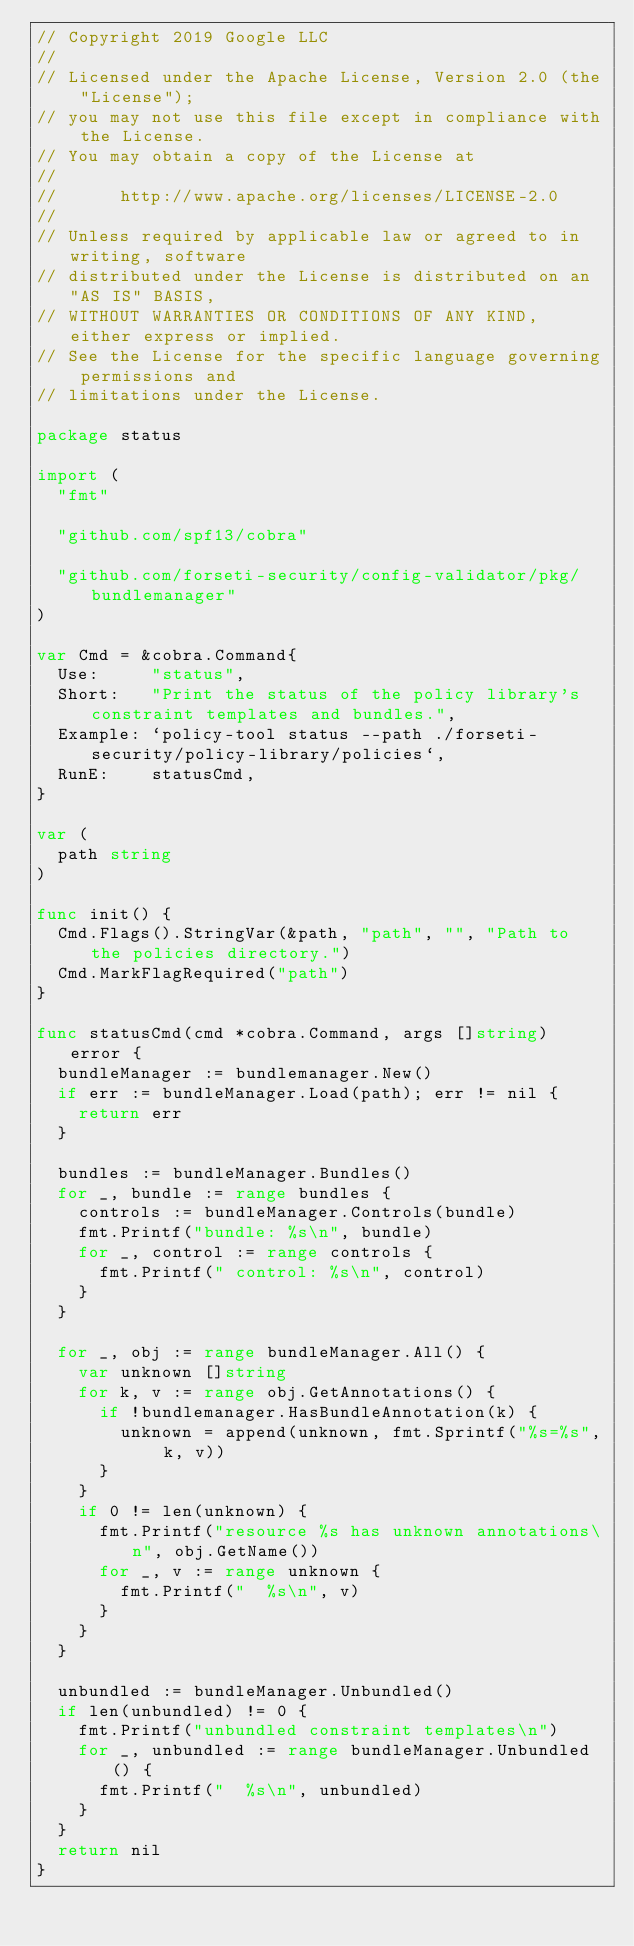Convert code to text. <code><loc_0><loc_0><loc_500><loc_500><_Go_>// Copyright 2019 Google LLC
//
// Licensed under the Apache License, Version 2.0 (the "License");
// you may not use this file except in compliance with the License.
// You may obtain a copy of the License at
//
//      http://www.apache.org/licenses/LICENSE-2.0
//
// Unless required by applicable law or agreed to in writing, software
// distributed under the License is distributed on an "AS IS" BASIS,
// WITHOUT WARRANTIES OR CONDITIONS OF ANY KIND, either express or implied.
// See the License for the specific language governing permissions and
// limitations under the License.

package status

import (
	"fmt"

	"github.com/spf13/cobra"

	"github.com/forseti-security/config-validator/pkg/bundlemanager"
)

var Cmd = &cobra.Command{
	Use:     "status",
	Short:   "Print the status of the policy library's constraint templates and bundles.",
	Example: `policy-tool status --path ./forseti-security/policy-library/policies`,
	RunE:    statusCmd,
}

var (
	path string
)

func init() {
	Cmd.Flags().StringVar(&path, "path", "", "Path to the policies directory.")
	Cmd.MarkFlagRequired("path")
}

func statusCmd(cmd *cobra.Command, args []string) error {
	bundleManager := bundlemanager.New()
	if err := bundleManager.Load(path); err != nil {
		return err
	}

	bundles := bundleManager.Bundles()
	for _, bundle := range bundles {
		controls := bundleManager.Controls(bundle)
		fmt.Printf("bundle: %s\n", bundle)
		for _, control := range controls {
			fmt.Printf(" control: %s\n", control)
		}
	}

	for _, obj := range bundleManager.All() {
		var unknown []string
		for k, v := range obj.GetAnnotations() {
			if !bundlemanager.HasBundleAnnotation(k) {
				unknown = append(unknown, fmt.Sprintf("%s=%s", k, v))
			}
		}
		if 0 != len(unknown) {
			fmt.Printf("resource %s has unknown annotations\n", obj.GetName())
			for _, v := range unknown {
				fmt.Printf("  %s\n", v)
			}
		}
	}

	unbundled := bundleManager.Unbundled()
	if len(unbundled) != 0 {
		fmt.Printf("unbundled constraint templates\n")
		for _, unbundled := range bundleManager.Unbundled() {
			fmt.Printf("  %s\n", unbundled)
		}
	}
	return nil
}
</code> 